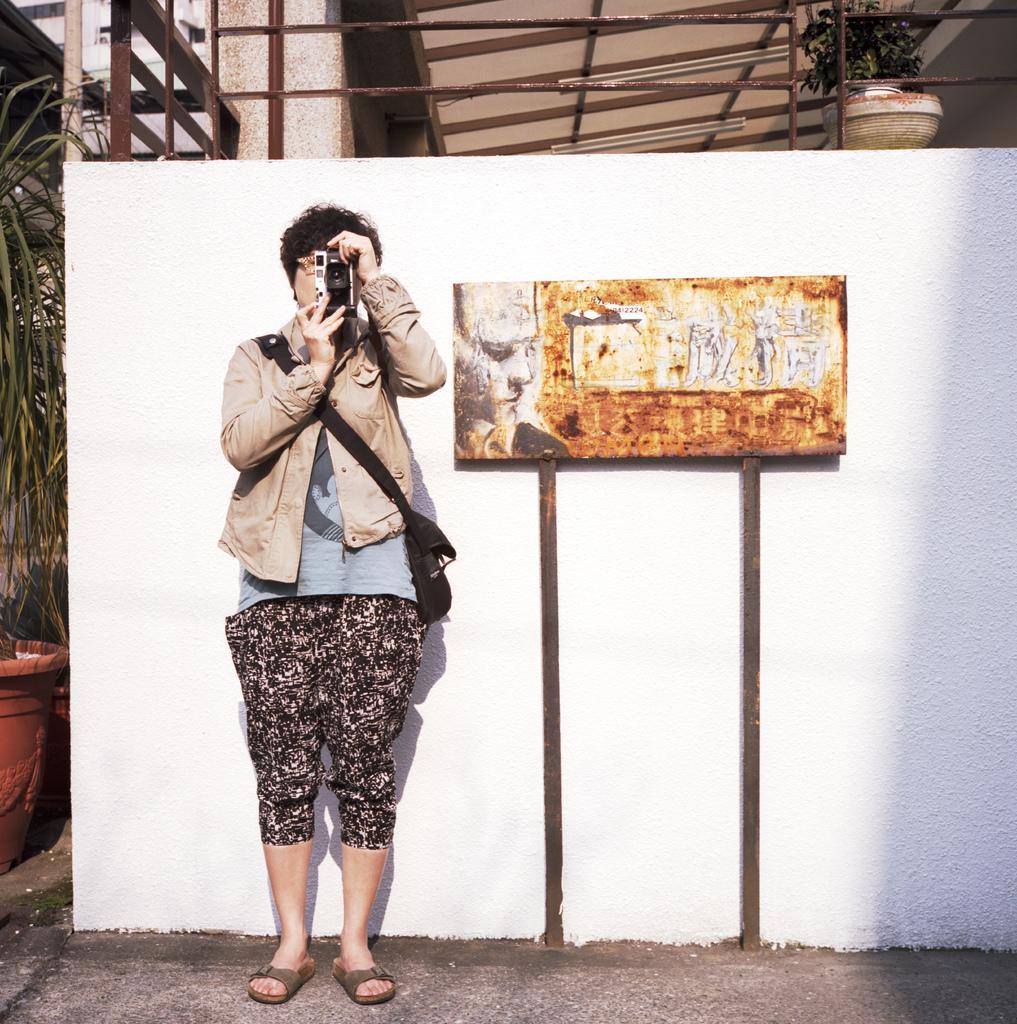How would you summarize this image in a sentence or two? In this image we can see a person standing and holding a camera, also we can see the wall and the board with some images, there are some potted plants, metal rods and a building. 